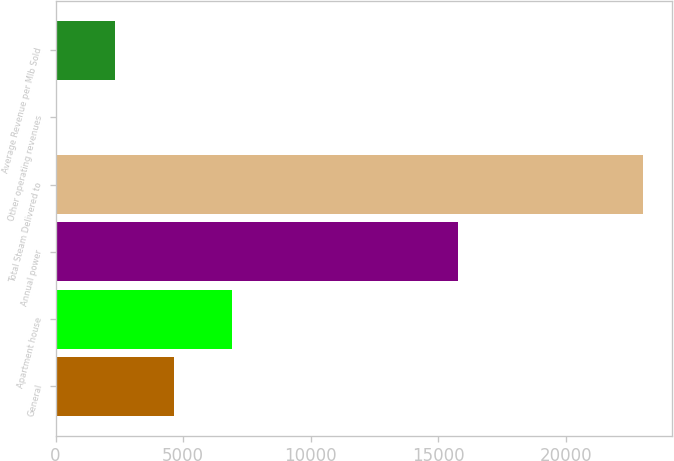<chart> <loc_0><loc_0><loc_500><loc_500><bar_chart><fcel>General<fcel>Apartment house<fcel>Annual power<fcel>Total Steam Delivered to<fcel>Other operating revenues<fcel>Average Revenue per Mlb Sold<nl><fcel>4621<fcel>6920.5<fcel>15748<fcel>23017<fcel>22<fcel>2321.5<nl></chart> 